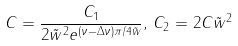Convert formula to latex. <formula><loc_0><loc_0><loc_500><loc_500>C = \frac { C _ { 1 } } { 2 \tilde { w } ^ { 2 } e ^ { ( \nu - \Delta \nu ) \pi / 4 \tilde { w } } } , \, C _ { 2 } = 2 C \tilde { w } ^ { 2 }</formula> 